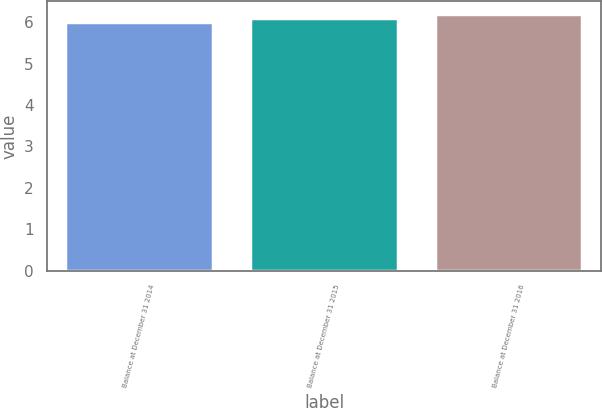Convert chart. <chart><loc_0><loc_0><loc_500><loc_500><bar_chart><fcel>Balance at December 31 2014<fcel>Balance at December 31 2015<fcel>Balance at December 31 2016<nl><fcel>6<fcel>6.1<fcel>6.2<nl></chart> 